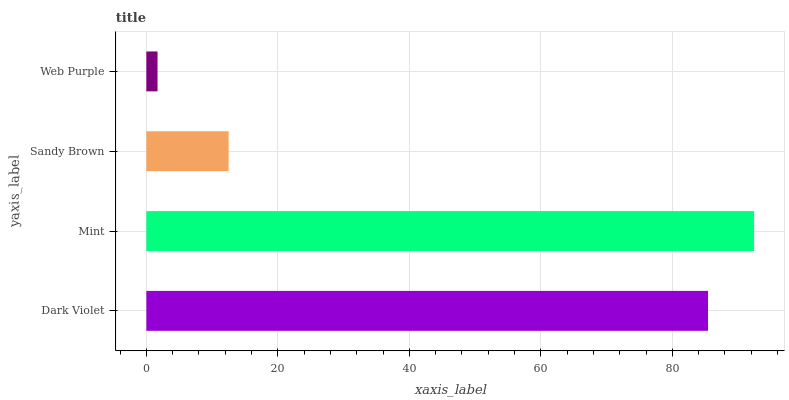Is Web Purple the minimum?
Answer yes or no. Yes. Is Mint the maximum?
Answer yes or no. Yes. Is Sandy Brown the minimum?
Answer yes or no. No. Is Sandy Brown the maximum?
Answer yes or no. No. Is Mint greater than Sandy Brown?
Answer yes or no. Yes. Is Sandy Brown less than Mint?
Answer yes or no. Yes. Is Sandy Brown greater than Mint?
Answer yes or no. No. Is Mint less than Sandy Brown?
Answer yes or no. No. Is Dark Violet the high median?
Answer yes or no. Yes. Is Sandy Brown the low median?
Answer yes or no. Yes. Is Mint the high median?
Answer yes or no. No. Is Web Purple the low median?
Answer yes or no. No. 